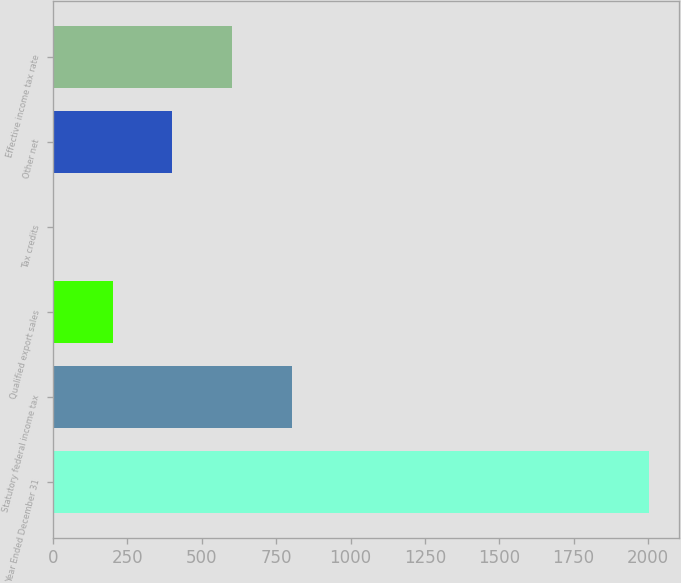Convert chart to OTSL. <chart><loc_0><loc_0><loc_500><loc_500><bar_chart><fcel>Year Ended December 31<fcel>Statutory federal income tax<fcel>Qualified export sales<fcel>Tax credits<fcel>Other net<fcel>Effective income tax rate<nl><fcel>2004<fcel>802.02<fcel>201.03<fcel>0.7<fcel>401.36<fcel>601.69<nl></chart> 